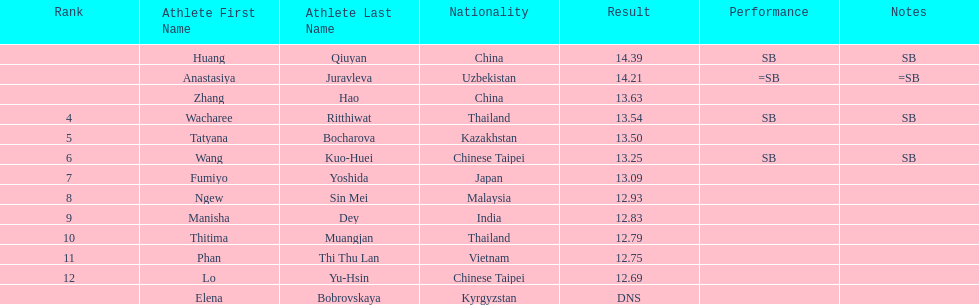What is the difference between huang qiuyan's result and fumiyo yoshida's result? 1.3. 